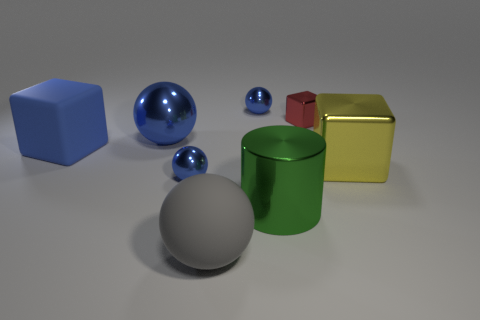There is a tiny blue ball in front of the yellow metallic block that is behind the matte sphere; what is its material?
Offer a terse response. Metal. There is a sphere that is in front of the small ball that is in front of the small blue thing behind the large metal sphere; what is its size?
Offer a terse response. Large. How many large yellow cubes have the same material as the large gray object?
Give a very brief answer. 0. What is the color of the big sphere in front of the large ball that is behind the big yellow block?
Provide a short and direct response. Gray. What number of objects are small gray shiny objects or large rubber things behind the yellow thing?
Your response must be concise. 1. Is there a object that has the same color as the shiny cylinder?
Make the answer very short. No. What number of yellow things are metallic blocks or tiny rubber cylinders?
Keep it short and to the point. 1. How many other things are the same size as the matte cube?
Offer a very short reply. 4. How many tiny things are either yellow shiny things or yellow metallic balls?
Offer a terse response. 0. Does the blue rubber block have the same size as the blue thing that is to the right of the large gray sphere?
Your answer should be very brief. No. 